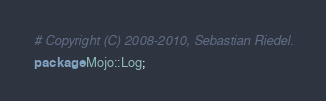Convert code to text. <code><loc_0><loc_0><loc_500><loc_500><_Perl_># Copyright (C) 2008-2010, Sebastian Riedel.

package Mojo::Log;
</code> 